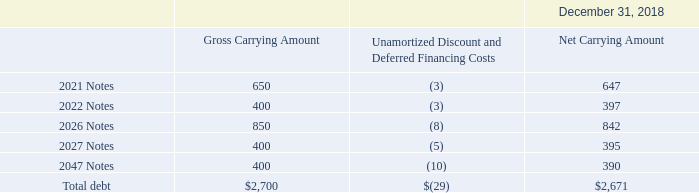A summary of our outstanding debt as of December 31, 2018, is as follows (amounts in millions):
Refer to Note 13 of the notes to the consolidated financial statements included in Item 8 of this Annual Report on Form 10-K for further disclosures regarding our debt obligations.
What was the gross carrying amount in the 2021 Notes?
Answer scale should be: million. 650. What was the gross carrying amount in the 2026 Notes?
Answer scale should be: million. 850. What was the net carrying amount in the 2047 Notes?
Answer scale should be: million. 390. What was the change in gross carrying amount between the 2022 and 2026 notes?
Answer scale should be: million. 850-400
Answer: 450. What was the change in gross carrying amount between the 2021 and 2022 notes?
Answer scale should be: million. 400-650
Answer: -250. What was the percentage change in the net carrying amount between the 2026 and 2027 notes?
Answer scale should be: percent. (395-842)/842
Answer: -53.09. 